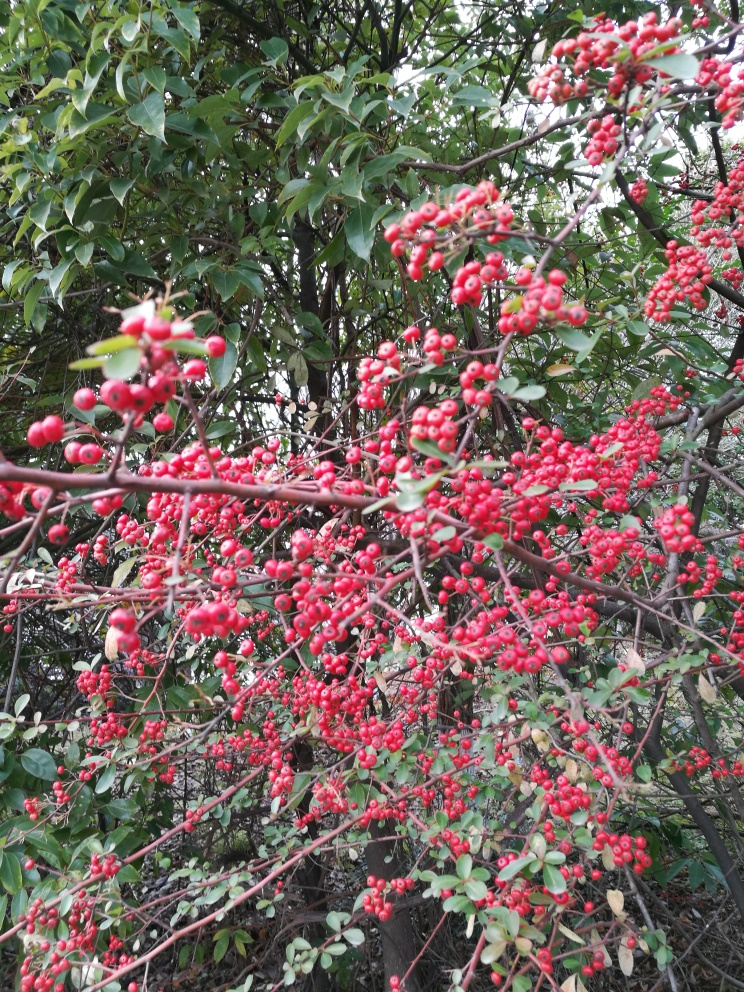Are the colors vivid? Yes, the colors are quite vivid. The image showcases a striking contrast between the bright red berries and the lush green leaves, creating a vibrant and lively visual effect. 